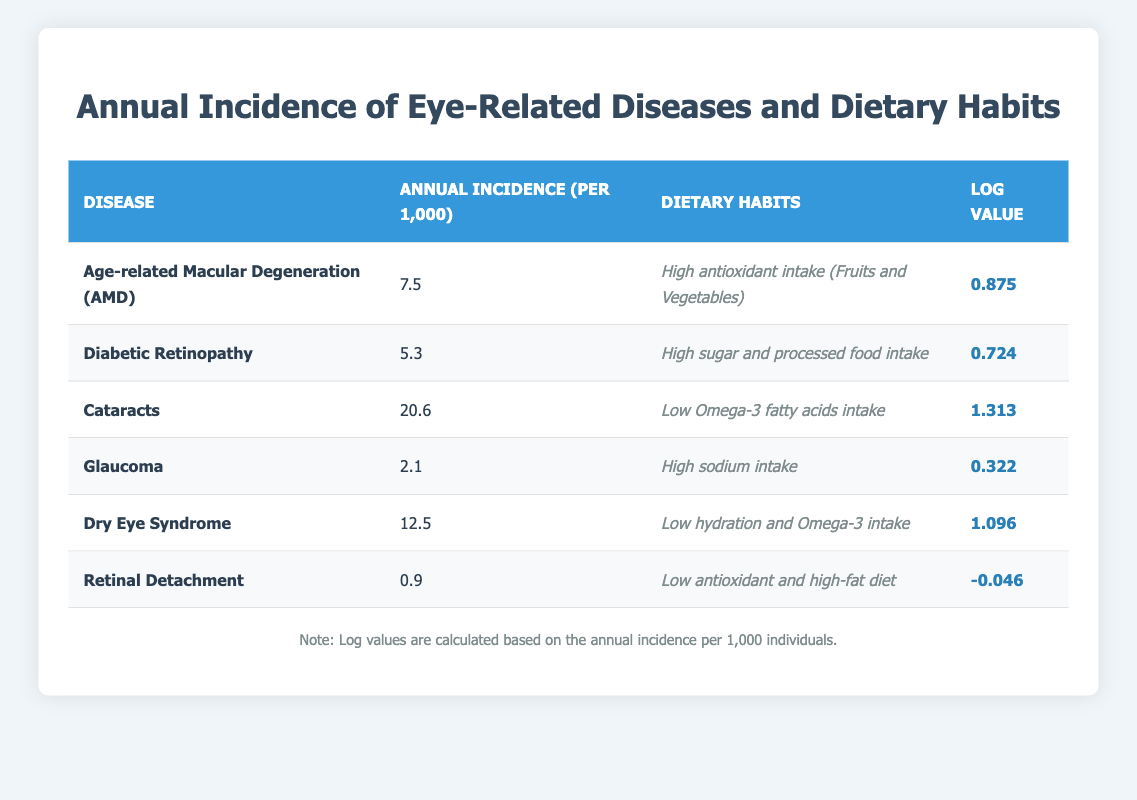What is the annual incidence of Age-related Macular Degeneration (AMD) per 1,000? The table states that the annual incidence of Age-related Macular Degeneration (AMD) is 7.5 per 1,000.
Answer: 7.5 Which disease has the highest annual incidence per 1,000? By comparing the values in the annual incidence column, Cataracts, with 20.6 per 1,000, has the highest annual incidence.
Answer: Cataracts What is the log value of Diabetic Retinopathy? The table indicates that the log value for Diabetic Retinopathy is 0.724.
Answer: 0.724 Which dietary habit is associated with the disease that has the lowest annual incidence? The disease with the lowest annual incidence is Retinal Detachment, which is associated with a "Low antioxidant and high-fat diet."
Answer: Low antioxidant and high-fat diet Calculate the average annual incidence for diseases with high antioxidant intake. Only Age-related Macular Degeneration (7.5) is listed under high antioxidant intake, so the average is 7.5/1 = 7.5.
Answer: 7.5 Is the annual incidence of Dry Eye Syndrome greater than 10 per 1,000? The annual incidence of Dry Eye Syndrome is 12.5 per 1,000, which is greater than 10.
Answer: Yes Are there any diseases listed with high sodium intake? Yes, Glaucoma is the disease associated with high sodium intake as per the dietary habits section of the table.
Answer: Yes What is the difference in annual incidence between Cataracts and Glaucoma? The annual incidence for Cataracts is 20.6 and for Glaucoma is 2.1. The difference is 20.6 - 2.1 = 18.5.
Answer: 18.5 Which disease has the highest log value, and what is that value? By reviewing the log values, Cataracts has the highest log value of 1.313.
Answer: Cataracts, 1.313 What is the total annual incidence for all diseases listed in the table? Adding all annual incidences: 7.5 (AMD) + 5.3 (Diabetic Retinopathy) + 20.6 (Cataracts) + 2.1 (Glaucoma) + 12.5 (Dry Eye Syndrome) + 0.9 (Retinal Detachment) = 49.9 per 1,000.
Answer: 49.9 